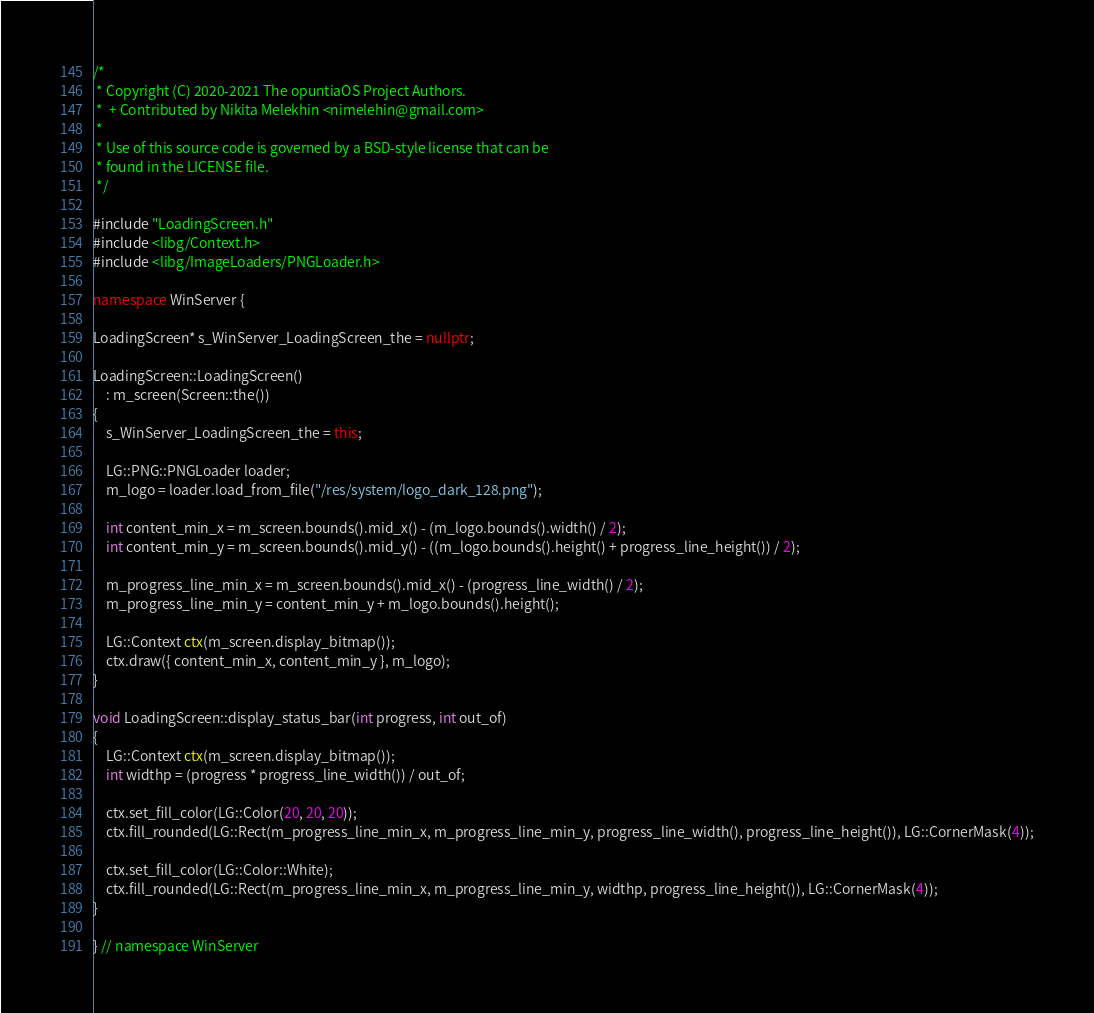<code> <loc_0><loc_0><loc_500><loc_500><_C++_>/*
 * Copyright (C) 2020-2021 The opuntiaOS Project Authors.
 *  + Contributed by Nikita Melekhin <nimelehin@gmail.com>
 *
 * Use of this source code is governed by a BSD-style license that can be
 * found in the LICENSE file.
 */

#include "LoadingScreen.h"
#include <libg/Context.h>
#include <libg/ImageLoaders/PNGLoader.h>

namespace WinServer {

LoadingScreen* s_WinServer_LoadingScreen_the = nullptr;

LoadingScreen::LoadingScreen()
    : m_screen(Screen::the())
{
    s_WinServer_LoadingScreen_the = this;

    LG::PNG::PNGLoader loader;
    m_logo = loader.load_from_file("/res/system/logo_dark_128.png");

    int content_min_x = m_screen.bounds().mid_x() - (m_logo.bounds().width() / 2);
    int content_min_y = m_screen.bounds().mid_y() - ((m_logo.bounds().height() + progress_line_height()) / 2);

    m_progress_line_min_x = m_screen.bounds().mid_x() - (progress_line_width() / 2);
    m_progress_line_min_y = content_min_y + m_logo.bounds().height();

    LG::Context ctx(m_screen.display_bitmap());
    ctx.draw({ content_min_x, content_min_y }, m_logo);
}

void LoadingScreen::display_status_bar(int progress, int out_of)
{
    LG::Context ctx(m_screen.display_bitmap());
    int widthp = (progress * progress_line_width()) / out_of;

    ctx.set_fill_color(LG::Color(20, 20, 20));
    ctx.fill_rounded(LG::Rect(m_progress_line_min_x, m_progress_line_min_y, progress_line_width(), progress_line_height()), LG::CornerMask(4));

    ctx.set_fill_color(LG::Color::White);
    ctx.fill_rounded(LG::Rect(m_progress_line_min_x, m_progress_line_min_y, widthp, progress_line_height()), LG::CornerMask(4));
}

} // namespace WinServer
</code> 